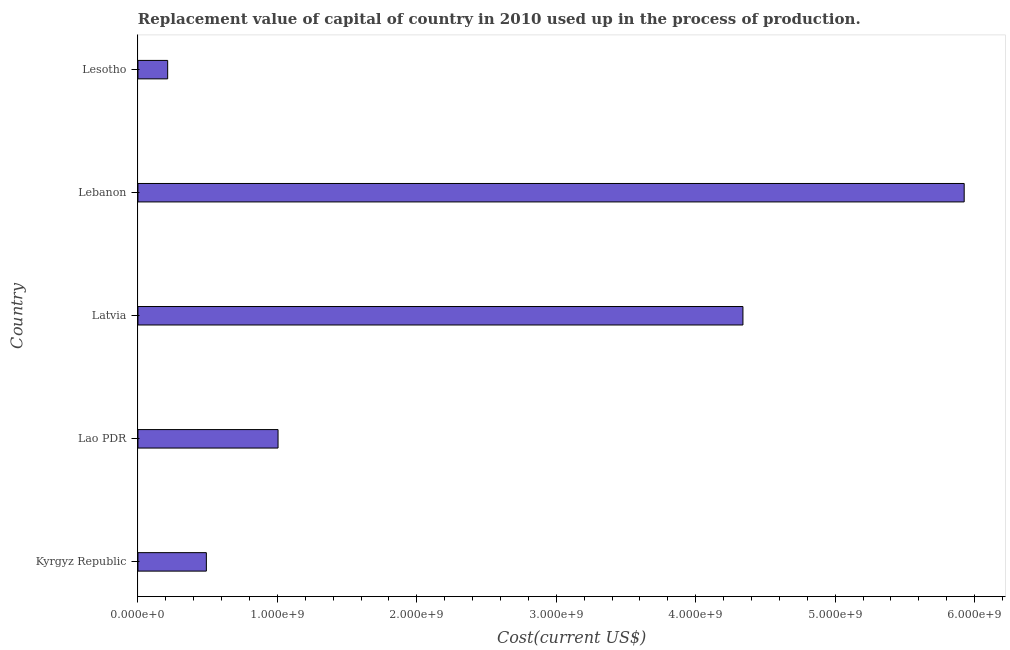Does the graph contain any zero values?
Ensure brevity in your answer.  No. Does the graph contain grids?
Give a very brief answer. No. What is the title of the graph?
Your response must be concise. Replacement value of capital of country in 2010 used up in the process of production. What is the label or title of the X-axis?
Give a very brief answer. Cost(current US$). What is the label or title of the Y-axis?
Offer a very short reply. Country. What is the consumption of fixed capital in Lebanon?
Your answer should be compact. 5.93e+09. Across all countries, what is the maximum consumption of fixed capital?
Provide a succinct answer. 5.93e+09. Across all countries, what is the minimum consumption of fixed capital?
Provide a short and direct response. 2.13e+08. In which country was the consumption of fixed capital maximum?
Ensure brevity in your answer.  Lebanon. In which country was the consumption of fixed capital minimum?
Your response must be concise. Lesotho. What is the sum of the consumption of fixed capital?
Provide a short and direct response. 1.20e+1. What is the difference between the consumption of fixed capital in Lebanon and Lesotho?
Offer a very short reply. 5.71e+09. What is the average consumption of fixed capital per country?
Provide a short and direct response. 2.39e+09. What is the median consumption of fixed capital?
Your response must be concise. 1.00e+09. In how many countries, is the consumption of fixed capital greater than 5600000000 US$?
Give a very brief answer. 1. What is the ratio of the consumption of fixed capital in Lebanon to that in Lesotho?
Make the answer very short. 27.8. Is the consumption of fixed capital in Lao PDR less than that in Latvia?
Offer a very short reply. Yes. What is the difference between the highest and the second highest consumption of fixed capital?
Offer a terse response. 1.59e+09. Is the sum of the consumption of fixed capital in Lao PDR and Lebanon greater than the maximum consumption of fixed capital across all countries?
Ensure brevity in your answer.  Yes. What is the difference between the highest and the lowest consumption of fixed capital?
Offer a very short reply. 5.71e+09. In how many countries, is the consumption of fixed capital greater than the average consumption of fixed capital taken over all countries?
Make the answer very short. 2. Are all the bars in the graph horizontal?
Make the answer very short. Yes. What is the difference between two consecutive major ticks on the X-axis?
Your answer should be compact. 1.00e+09. What is the Cost(current US$) of Kyrgyz Republic?
Your answer should be very brief. 4.91e+08. What is the Cost(current US$) in Lao PDR?
Ensure brevity in your answer.  1.00e+09. What is the Cost(current US$) in Latvia?
Your answer should be very brief. 4.34e+09. What is the Cost(current US$) in Lebanon?
Provide a short and direct response. 5.93e+09. What is the Cost(current US$) of Lesotho?
Make the answer very short. 2.13e+08. What is the difference between the Cost(current US$) in Kyrgyz Republic and Lao PDR?
Your answer should be very brief. -5.14e+08. What is the difference between the Cost(current US$) in Kyrgyz Republic and Latvia?
Provide a succinct answer. -3.85e+09. What is the difference between the Cost(current US$) in Kyrgyz Republic and Lebanon?
Provide a short and direct response. -5.43e+09. What is the difference between the Cost(current US$) in Kyrgyz Republic and Lesotho?
Provide a succinct answer. 2.77e+08. What is the difference between the Cost(current US$) in Lao PDR and Latvia?
Keep it short and to the point. -3.33e+09. What is the difference between the Cost(current US$) in Lao PDR and Lebanon?
Your response must be concise. -4.92e+09. What is the difference between the Cost(current US$) in Lao PDR and Lesotho?
Make the answer very short. 7.92e+08. What is the difference between the Cost(current US$) in Latvia and Lebanon?
Ensure brevity in your answer.  -1.59e+09. What is the difference between the Cost(current US$) in Latvia and Lesotho?
Give a very brief answer. 4.13e+09. What is the difference between the Cost(current US$) in Lebanon and Lesotho?
Your response must be concise. 5.71e+09. What is the ratio of the Cost(current US$) in Kyrgyz Republic to that in Lao PDR?
Ensure brevity in your answer.  0.49. What is the ratio of the Cost(current US$) in Kyrgyz Republic to that in Latvia?
Make the answer very short. 0.11. What is the ratio of the Cost(current US$) in Kyrgyz Republic to that in Lebanon?
Provide a succinct answer. 0.08. What is the ratio of the Cost(current US$) in Kyrgyz Republic to that in Lesotho?
Your answer should be very brief. 2.3. What is the ratio of the Cost(current US$) in Lao PDR to that in Latvia?
Ensure brevity in your answer.  0.23. What is the ratio of the Cost(current US$) in Lao PDR to that in Lebanon?
Offer a very short reply. 0.17. What is the ratio of the Cost(current US$) in Lao PDR to that in Lesotho?
Your answer should be very brief. 4.71. What is the ratio of the Cost(current US$) in Latvia to that in Lebanon?
Your answer should be very brief. 0.73. What is the ratio of the Cost(current US$) in Latvia to that in Lesotho?
Offer a very short reply. 20.36. What is the ratio of the Cost(current US$) in Lebanon to that in Lesotho?
Provide a short and direct response. 27.8. 